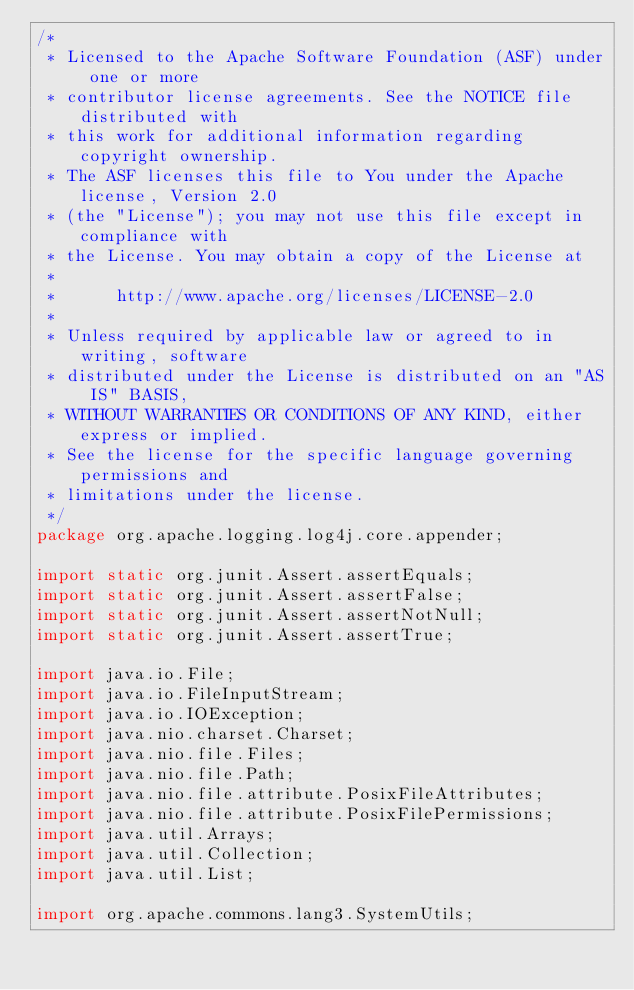<code> <loc_0><loc_0><loc_500><loc_500><_Java_>/*
 * Licensed to the Apache Software Foundation (ASF) under one or more
 * contributor license agreements. See the NOTICE file distributed with
 * this work for additional information regarding copyright ownership.
 * The ASF licenses this file to You under the Apache license, Version 2.0
 * (the "License"); you may not use this file except in compliance with
 * the License. You may obtain a copy of the License at
 *
 *      http://www.apache.org/licenses/LICENSE-2.0
 *
 * Unless required by applicable law or agreed to in writing, software
 * distributed under the License is distributed on an "AS IS" BASIS,
 * WITHOUT WARRANTIES OR CONDITIONS OF ANY KIND, either express or implied.
 * See the license for the specific language governing permissions and
 * limitations under the license.
 */
package org.apache.logging.log4j.core.appender;

import static org.junit.Assert.assertEquals;
import static org.junit.Assert.assertFalse;
import static org.junit.Assert.assertNotNull;
import static org.junit.Assert.assertTrue;

import java.io.File;
import java.io.FileInputStream;
import java.io.IOException;
import java.nio.charset.Charset;
import java.nio.file.Files;
import java.nio.file.Path;
import java.nio.file.attribute.PosixFileAttributes;
import java.nio.file.attribute.PosixFilePermissions;
import java.util.Arrays;
import java.util.Collection;
import java.util.List;

import org.apache.commons.lang3.SystemUtils;</code> 